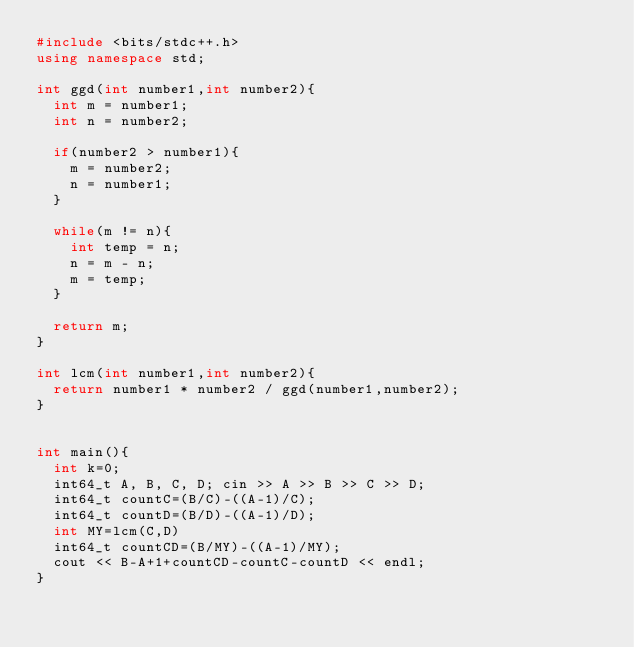Convert code to text. <code><loc_0><loc_0><loc_500><loc_500><_C++_>#include <bits/stdc++.h>
using namespace std;

int ggd(int number1,int number2){
	int m = number1;
	int n = number2;

	if(number2 > number1){
		m = number2;
		n = number1;
	}

	while(m != n){
		int temp = n;
		n = m - n;
		m = temp;
	}

	return m;
}

int lcm(int number1,int number2){
	return number1 * number2 / ggd(number1,number2);	
}


int main(){
  int k=0;
  int64_t A, B, C, D; cin >> A >> B >> C >> D;
  int64_t countC=(B/C)-((A-1)/C);
  int64_t countD=(B/D)-((A-1)/D);
  int MY=lcm(C,D)
  int64_t countCD=(B/MY)-((A-1)/MY);
  cout << B-A+1+countCD-countC-countD << endl;
}
  </code> 